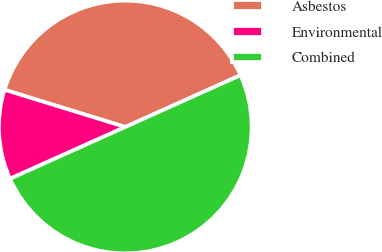<chart> <loc_0><loc_0><loc_500><loc_500><pie_chart><fcel>Asbestos<fcel>Environmental<fcel>Combined<nl><fcel>38.52%<fcel>11.48%<fcel>50.0%<nl></chart> 